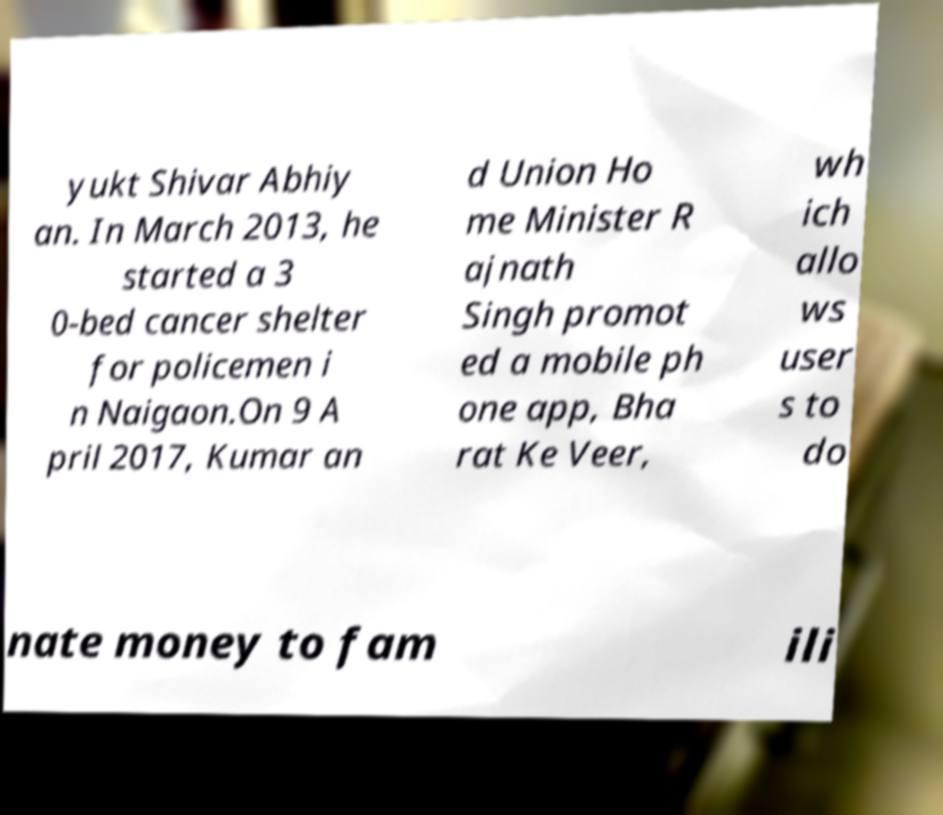For documentation purposes, I need the text within this image transcribed. Could you provide that? yukt Shivar Abhiy an. In March 2013, he started a 3 0-bed cancer shelter for policemen i n Naigaon.On 9 A pril 2017, Kumar an d Union Ho me Minister R ajnath Singh promot ed a mobile ph one app, Bha rat Ke Veer, wh ich allo ws user s to do nate money to fam ili 